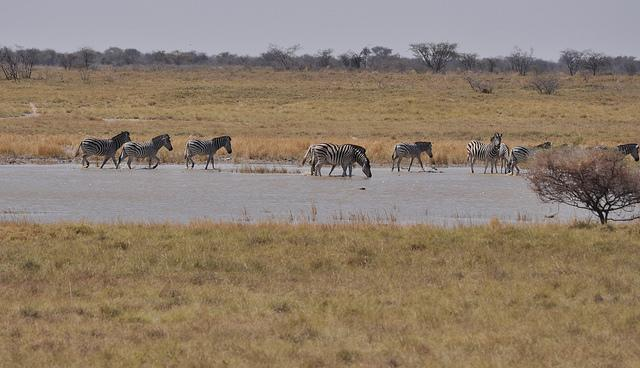What direction are the animals facing? right 